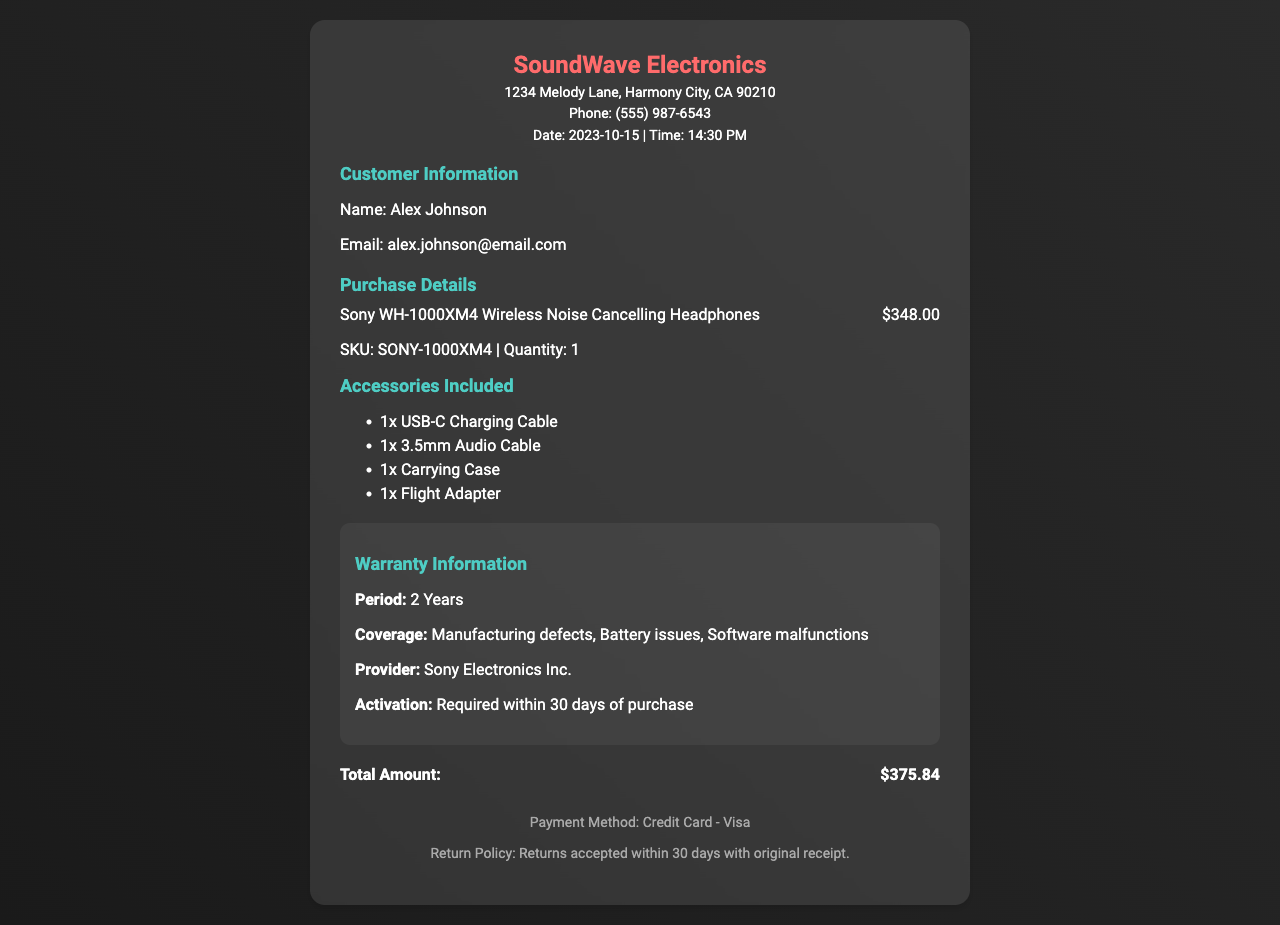What is the store name? The store name is prominently displayed at the top of the receipt.
Answer: SoundWave Electronics What is the purchase date? The purchase date is included in the store information section.
Answer: 2023-10-15 What is the total amount spent? The total amount is shown at the bottom of the receipt.
Answer: $375.84 What accessories are included with the headphones? A list of included accessories is provided in a dedicated section.
Answer: USB-C Charging Cable, 3.5mm Audio Cable, Carrying Case, Flight Adapter What is the warranty period? The warranty information section specifies the coverage duration.
Answer: 2 Years Who is the warranty provider? The warranty information clearly states the name of the provider.
Answer: Sony Electronics Inc What is the return policy duration? The return policy is detailed at the bottom of the receipt.
Answer: 30 days What payment method was used? The payment method is mentioned in the footer of the receipt.
Answer: Credit Card - Visa What is the quantity of headphones purchased? The quantity is indicated alongside the SKU information.
Answer: 1 